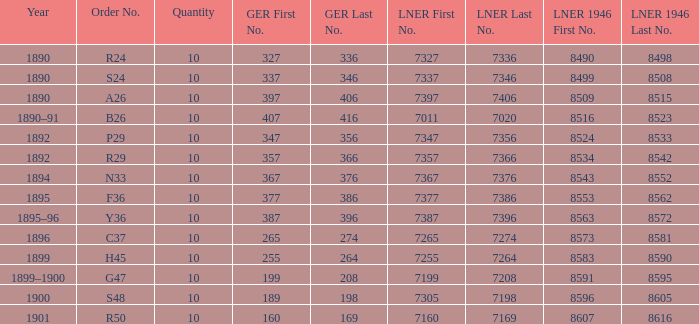What is order S24's LNER 1946 number? 8499–8505, —, 8507–8508. 